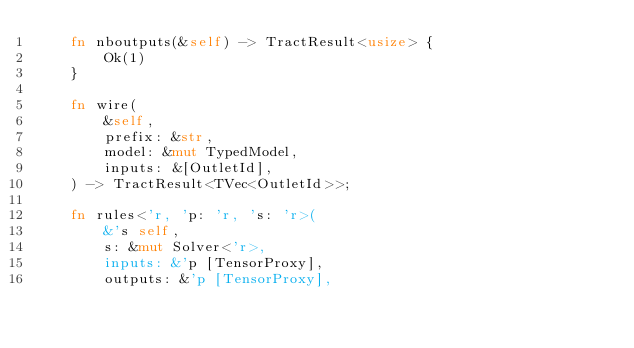Convert code to text. <code><loc_0><loc_0><loc_500><loc_500><_Rust_>    fn nboutputs(&self) -> TractResult<usize> {
        Ok(1)
    }

    fn wire(
        &self,
        prefix: &str,
        model: &mut TypedModel,
        inputs: &[OutletId],
    ) -> TractResult<TVec<OutletId>>;

    fn rules<'r, 'p: 'r, 's: 'r>(
        &'s self,
        s: &mut Solver<'r>,
        inputs: &'p [TensorProxy],
        outputs: &'p [TensorProxy],</code> 